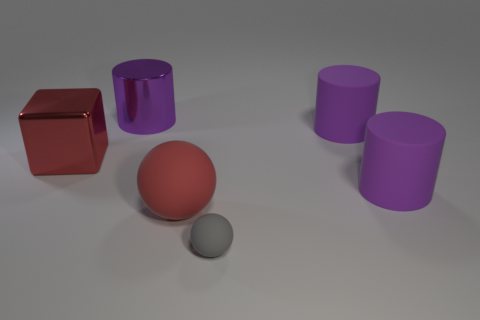What shape is the big rubber thing left of the small gray matte object in front of the large purple metal cylinder?
Your response must be concise. Sphere. The big matte object that is behind the block is what color?
Make the answer very short. Purple. What size is the other ball that is made of the same material as the gray sphere?
Offer a terse response. Large. There is another thing that is the same shape as the tiny rubber thing; what size is it?
Make the answer very short. Large. Are there any spheres?
Your response must be concise. Yes. How many things are either things that are on the left side of the red rubber object or red rubber balls?
Give a very brief answer. 3. There is a red object that is the same size as the red cube; what is it made of?
Give a very brief answer. Rubber. What is the color of the sphere that is left of the matte sphere that is in front of the big matte ball?
Offer a very short reply. Red. What number of matte objects are in front of the big red rubber sphere?
Your answer should be very brief. 1. What color is the tiny sphere?
Offer a terse response. Gray. 